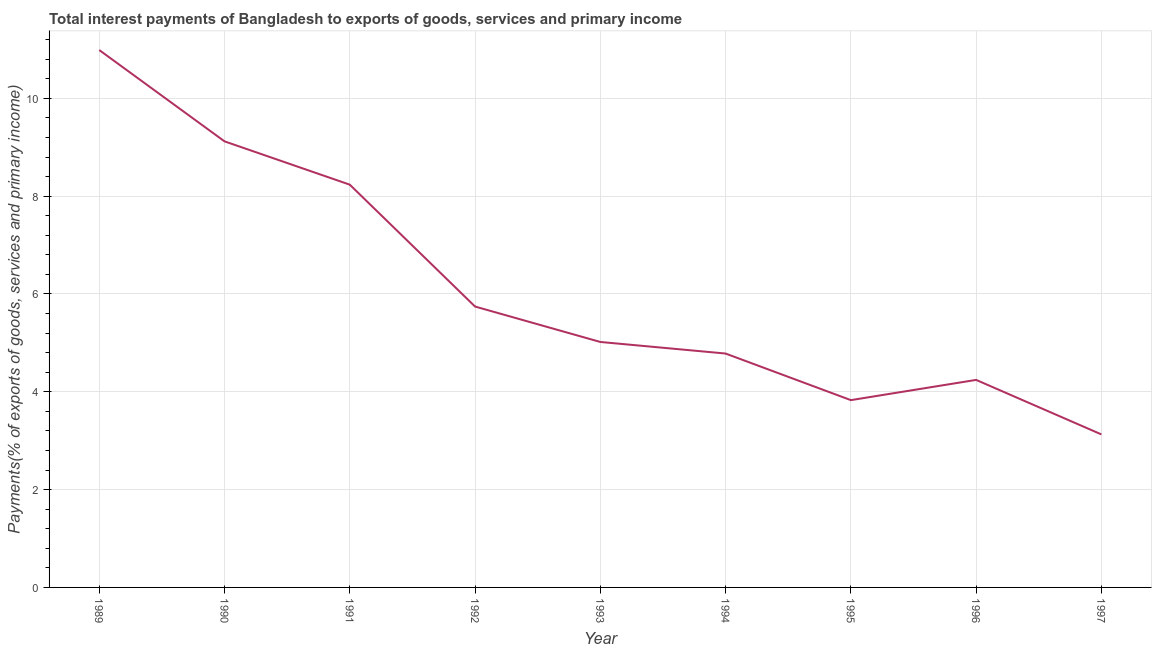What is the total interest payments on external debt in 1997?
Your answer should be compact. 3.13. Across all years, what is the maximum total interest payments on external debt?
Provide a succinct answer. 10.99. Across all years, what is the minimum total interest payments on external debt?
Your response must be concise. 3.13. In which year was the total interest payments on external debt maximum?
Provide a succinct answer. 1989. In which year was the total interest payments on external debt minimum?
Provide a short and direct response. 1997. What is the sum of the total interest payments on external debt?
Make the answer very short. 55.09. What is the difference between the total interest payments on external debt in 1989 and 1993?
Your response must be concise. 5.97. What is the average total interest payments on external debt per year?
Make the answer very short. 6.12. What is the median total interest payments on external debt?
Provide a succinct answer. 5.02. Do a majority of the years between 1993 and 1997 (inclusive) have total interest payments on external debt greater than 1.2000000000000002 %?
Provide a succinct answer. Yes. What is the ratio of the total interest payments on external debt in 1992 to that in 1996?
Provide a succinct answer. 1.35. Is the total interest payments on external debt in 1992 less than that in 1994?
Keep it short and to the point. No. Is the difference between the total interest payments on external debt in 1996 and 1997 greater than the difference between any two years?
Give a very brief answer. No. What is the difference between the highest and the second highest total interest payments on external debt?
Your answer should be compact. 1.87. What is the difference between the highest and the lowest total interest payments on external debt?
Your response must be concise. 7.86. In how many years, is the total interest payments on external debt greater than the average total interest payments on external debt taken over all years?
Offer a very short reply. 3. How many lines are there?
Offer a terse response. 1. How many years are there in the graph?
Provide a short and direct response. 9. What is the difference between two consecutive major ticks on the Y-axis?
Your response must be concise. 2. Does the graph contain any zero values?
Make the answer very short. No. What is the title of the graph?
Give a very brief answer. Total interest payments of Bangladesh to exports of goods, services and primary income. What is the label or title of the Y-axis?
Keep it short and to the point. Payments(% of exports of goods, services and primary income). What is the Payments(% of exports of goods, services and primary income) of 1989?
Your answer should be compact. 10.99. What is the Payments(% of exports of goods, services and primary income) in 1990?
Offer a very short reply. 9.12. What is the Payments(% of exports of goods, services and primary income) in 1991?
Keep it short and to the point. 8.23. What is the Payments(% of exports of goods, services and primary income) of 1992?
Provide a short and direct response. 5.74. What is the Payments(% of exports of goods, services and primary income) in 1993?
Offer a terse response. 5.02. What is the Payments(% of exports of goods, services and primary income) of 1994?
Your answer should be very brief. 4.78. What is the Payments(% of exports of goods, services and primary income) of 1995?
Your answer should be very brief. 3.83. What is the Payments(% of exports of goods, services and primary income) of 1996?
Offer a terse response. 4.24. What is the Payments(% of exports of goods, services and primary income) in 1997?
Make the answer very short. 3.13. What is the difference between the Payments(% of exports of goods, services and primary income) in 1989 and 1990?
Your response must be concise. 1.87. What is the difference between the Payments(% of exports of goods, services and primary income) in 1989 and 1991?
Keep it short and to the point. 2.75. What is the difference between the Payments(% of exports of goods, services and primary income) in 1989 and 1992?
Your answer should be compact. 5.24. What is the difference between the Payments(% of exports of goods, services and primary income) in 1989 and 1993?
Your answer should be very brief. 5.97. What is the difference between the Payments(% of exports of goods, services and primary income) in 1989 and 1994?
Make the answer very short. 6.21. What is the difference between the Payments(% of exports of goods, services and primary income) in 1989 and 1995?
Your response must be concise. 7.16. What is the difference between the Payments(% of exports of goods, services and primary income) in 1989 and 1996?
Make the answer very short. 6.74. What is the difference between the Payments(% of exports of goods, services and primary income) in 1989 and 1997?
Ensure brevity in your answer.  7.86. What is the difference between the Payments(% of exports of goods, services and primary income) in 1990 and 1991?
Provide a short and direct response. 0.89. What is the difference between the Payments(% of exports of goods, services and primary income) in 1990 and 1992?
Offer a very short reply. 3.38. What is the difference between the Payments(% of exports of goods, services and primary income) in 1990 and 1993?
Offer a very short reply. 4.1. What is the difference between the Payments(% of exports of goods, services and primary income) in 1990 and 1994?
Ensure brevity in your answer.  4.34. What is the difference between the Payments(% of exports of goods, services and primary income) in 1990 and 1995?
Offer a very short reply. 5.29. What is the difference between the Payments(% of exports of goods, services and primary income) in 1990 and 1996?
Offer a terse response. 4.88. What is the difference between the Payments(% of exports of goods, services and primary income) in 1990 and 1997?
Keep it short and to the point. 5.99. What is the difference between the Payments(% of exports of goods, services and primary income) in 1991 and 1992?
Keep it short and to the point. 2.49. What is the difference between the Payments(% of exports of goods, services and primary income) in 1991 and 1993?
Provide a succinct answer. 3.22. What is the difference between the Payments(% of exports of goods, services and primary income) in 1991 and 1994?
Offer a very short reply. 3.45. What is the difference between the Payments(% of exports of goods, services and primary income) in 1991 and 1995?
Ensure brevity in your answer.  4.41. What is the difference between the Payments(% of exports of goods, services and primary income) in 1991 and 1996?
Offer a terse response. 3.99. What is the difference between the Payments(% of exports of goods, services and primary income) in 1991 and 1997?
Your answer should be very brief. 5.11. What is the difference between the Payments(% of exports of goods, services and primary income) in 1992 and 1993?
Keep it short and to the point. 0.72. What is the difference between the Payments(% of exports of goods, services and primary income) in 1992 and 1994?
Provide a succinct answer. 0.96. What is the difference between the Payments(% of exports of goods, services and primary income) in 1992 and 1995?
Make the answer very short. 1.91. What is the difference between the Payments(% of exports of goods, services and primary income) in 1992 and 1996?
Provide a succinct answer. 1.5. What is the difference between the Payments(% of exports of goods, services and primary income) in 1992 and 1997?
Your answer should be very brief. 2.61. What is the difference between the Payments(% of exports of goods, services and primary income) in 1993 and 1994?
Provide a short and direct response. 0.24. What is the difference between the Payments(% of exports of goods, services and primary income) in 1993 and 1995?
Provide a short and direct response. 1.19. What is the difference between the Payments(% of exports of goods, services and primary income) in 1993 and 1996?
Provide a short and direct response. 0.78. What is the difference between the Payments(% of exports of goods, services and primary income) in 1993 and 1997?
Make the answer very short. 1.89. What is the difference between the Payments(% of exports of goods, services and primary income) in 1994 and 1995?
Give a very brief answer. 0.95. What is the difference between the Payments(% of exports of goods, services and primary income) in 1994 and 1996?
Make the answer very short. 0.54. What is the difference between the Payments(% of exports of goods, services and primary income) in 1994 and 1997?
Your response must be concise. 1.65. What is the difference between the Payments(% of exports of goods, services and primary income) in 1995 and 1996?
Your response must be concise. -0.41. What is the difference between the Payments(% of exports of goods, services and primary income) in 1995 and 1997?
Ensure brevity in your answer.  0.7. What is the difference between the Payments(% of exports of goods, services and primary income) in 1996 and 1997?
Your answer should be very brief. 1.11. What is the ratio of the Payments(% of exports of goods, services and primary income) in 1989 to that in 1990?
Provide a succinct answer. 1.21. What is the ratio of the Payments(% of exports of goods, services and primary income) in 1989 to that in 1991?
Offer a very short reply. 1.33. What is the ratio of the Payments(% of exports of goods, services and primary income) in 1989 to that in 1992?
Make the answer very short. 1.91. What is the ratio of the Payments(% of exports of goods, services and primary income) in 1989 to that in 1993?
Provide a succinct answer. 2.19. What is the ratio of the Payments(% of exports of goods, services and primary income) in 1989 to that in 1994?
Provide a succinct answer. 2.3. What is the ratio of the Payments(% of exports of goods, services and primary income) in 1989 to that in 1995?
Make the answer very short. 2.87. What is the ratio of the Payments(% of exports of goods, services and primary income) in 1989 to that in 1996?
Your answer should be very brief. 2.59. What is the ratio of the Payments(% of exports of goods, services and primary income) in 1989 to that in 1997?
Ensure brevity in your answer.  3.51. What is the ratio of the Payments(% of exports of goods, services and primary income) in 1990 to that in 1991?
Your response must be concise. 1.11. What is the ratio of the Payments(% of exports of goods, services and primary income) in 1990 to that in 1992?
Make the answer very short. 1.59. What is the ratio of the Payments(% of exports of goods, services and primary income) in 1990 to that in 1993?
Make the answer very short. 1.82. What is the ratio of the Payments(% of exports of goods, services and primary income) in 1990 to that in 1994?
Provide a short and direct response. 1.91. What is the ratio of the Payments(% of exports of goods, services and primary income) in 1990 to that in 1995?
Give a very brief answer. 2.38. What is the ratio of the Payments(% of exports of goods, services and primary income) in 1990 to that in 1996?
Provide a short and direct response. 2.15. What is the ratio of the Payments(% of exports of goods, services and primary income) in 1990 to that in 1997?
Offer a terse response. 2.92. What is the ratio of the Payments(% of exports of goods, services and primary income) in 1991 to that in 1992?
Provide a short and direct response. 1.43. What is the ratio of the Payments(% of exports of goods, services and primary income) in 1991 to that in 1993?
Your answer should be compact. 1.64. What is the ratio of the Payments(% of exports of goods, services and primary income) in 1991 to that in 1994?
Provide a succinct answer. 1.72. What is the ratio of the Payments(% of exports of goods, services and primary income) in 1991 to that in 1995?
Your answer should be very brief. 2.15. What is the ratio of the Payments(% of exports of goods, services and primary income) in 1991 to that in 1996?
Your answer should be compact. 1.94. What is the ratio of the Payments(% of exports of goods, services and primary income) in 1991 to that in 1997?
Your answer should be compact. 2.63. What is the ratio of the Payments(% of exports of goods, services and primary income) in 1992 to that in 1993?
Your response must be concise. 1.14. What is the ratio of the Payments(% of exports of goods, services and primary income) in 1992 to that in 1994?
Make the answer very short. 1.2. What is the ratio of the Payments(% of exports of goods, services and primary income) in 1992 to that in 1995?
Ensure brevity in your answer.  1.5. What is the ratio of the Payments(% of exports of goods, services and primary income) in 1992 to that in 1996?
Keep it short and to the point. 1.35. What is the ratio of the Payments(% of exports of goods, services and primary income) in 1992 to that in 1997?
Provide a short and direct response. 1.84. What is the ratio of the Payments(% of exports of goods, services and primary income) in 1993 to that in 1994?
Make the answer very short. 1.05. What is the ratio of the Payments(% of exports of goods, services and primary income) in 1993 to that in 1995?
Give a very brief answer. 1.31. What is the ratio of the Payments(% of exports of goods, services and primary income) in 1993 to that in 1996?
Offer a very short reply. 1.18. What is the ratio of the Payments(% of exports of goods, services and primary income) in 1993 to that in 1997?
Make the answer very short. 1.6. What is the ratio of the Payments(% of exports of goods, services and primary income) in 1994 to that in 1995?
Keep it short and to the point. 1.25. What is the ratio of the Payments(% of exports of goods, services and primary income) in 1994 to that in 1996?
Make the answer very short. 1.13. What is the ratio of the Payments(% of exports of goods, services and primary income) in 1994 to that in 1997?
Your response must be concise. 1.53. What is the ratio of the Payments(% of exports of goods, services and primary income) in 1995 to that in 1996?
Give a very brief answer. 0.9. What is the ratio of the Payments(% of exports of goods, services and primary income) in 1995 to that in 1997?
Your answer should be compact. 1.22. What is the ratio of the Payments(% of exports of goods, services and primary income) in 1996 to that in 1997?
Your response must be concise. 1.36. 